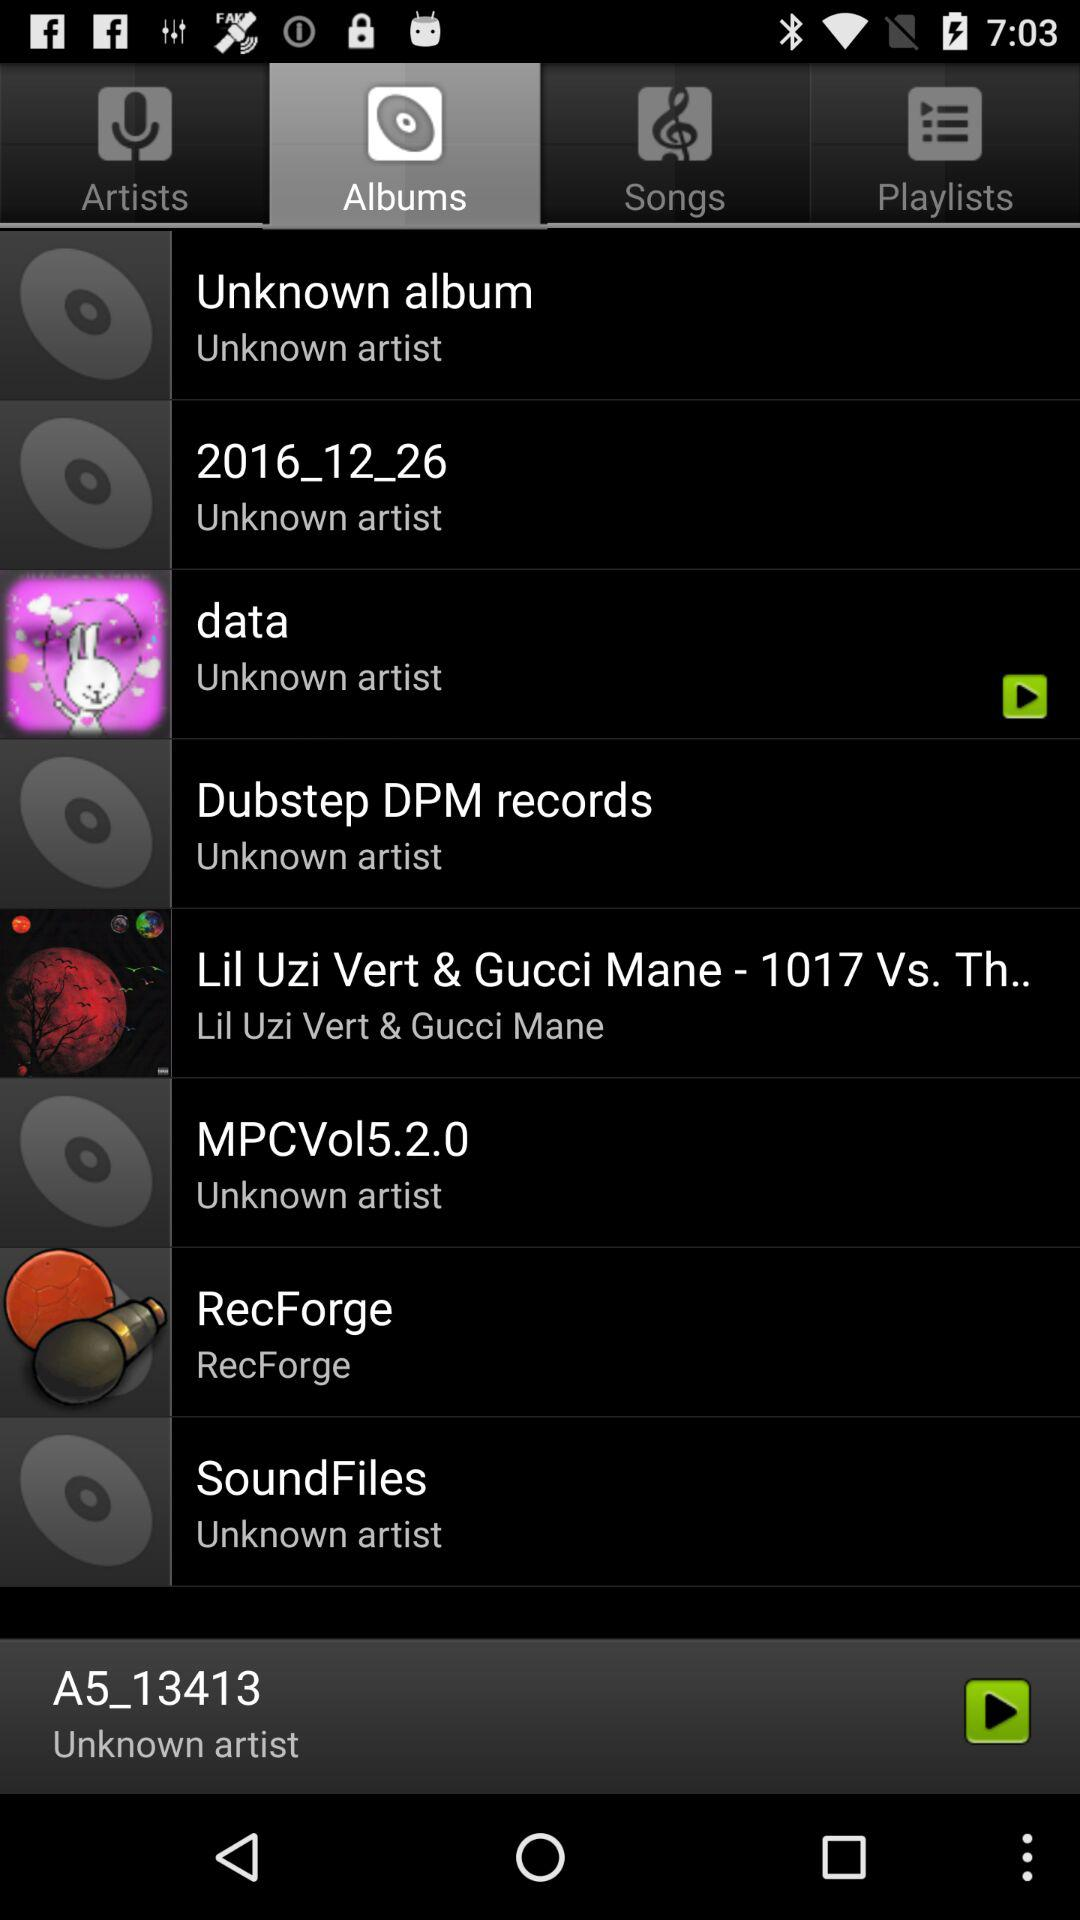Which audio was last played? The last played audio was "A5_13413". 